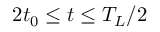Convert formula to latex. <formula><loc_0><loc_0><loc_500><loc_500>2 t _ { 0 } \leq t \leq T _ { L } / 2</formula> 